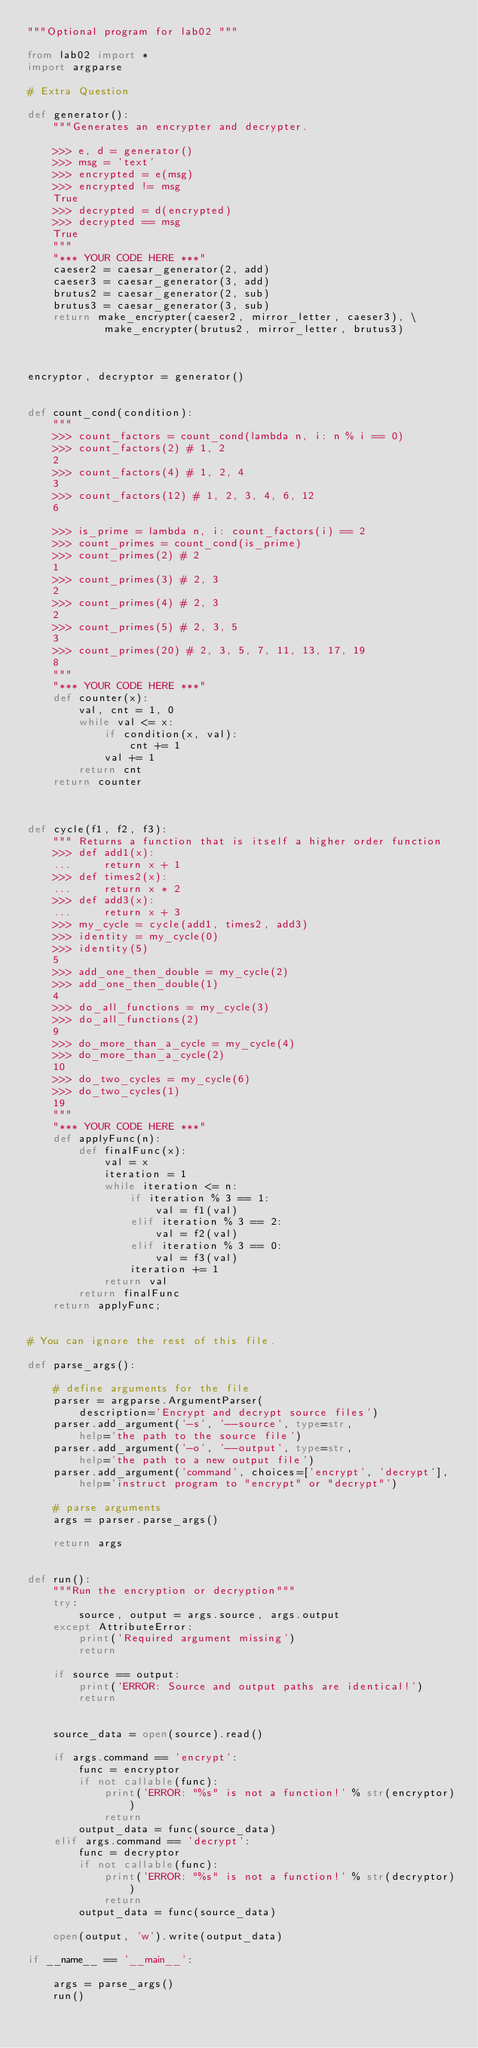<code> <loc_0><loc_0><loc_500><loc_500><_Python_>"""Optional program for lab02 """

from lab02 import *
import argparse

# Extra Question

def generator():
    """Generates an encrypter and decrypter.

    >>> e, d = generator()
    >>> msg = 'text'
    >>> encrypted = e(msg)
    >>> encrypted != msg
    True
    >>> decrypted = d(encrypted)
    >>> decrypted == msg
    True
    """
    "*** YOUR CODE HERE ***"
    caeser2 = caesar_generator(2, add)
    caeser3 = caesar_generator(3, add)
    brutus2 = caesar_generator(2, sub)
    brutus3 = caesar_generator(3, sub)
    return make_encrypter(caeser2, mirror_letter, caeser3), \
            make_encrypter(brutus2, mirror_letter, brutus3)
    


encryptor, decryptor = generator()


def count_cond(condition):
    """
    >>> count_factors = count_cond(lambda n, i: n % i == 0)
    >>> count_factors(2) # 1, 2
    2
    >>> count_factors(4) # 1, 2, 4
    3
    >>> count_factors(12) # 1, 2, 3, 4, 6, 12
    6

    >>> is_prime = lambda n, i: count_factors(i) == 2
    >>> count_primes = count_cond(is_prime)
    >>> count_primes(2) # 2
    1
    >>> count_primes(3) # 2, 3
    2
    >>> count_primes(4) # 2, 3
    2
    >>> count_primes(5) # 2, 3, 5
    3
    >>> count_primes(20) # 2, 3, 5, 7, 11, 13, 17, 19
    8
    """
    "*** YOUR CODE HERE ***"
    def counter(x):
        val, cnt = 1, 0
        while val <= x:
            if condition(x, val):
                cnt += 1
            val += 1
        return cnt
    return counter



def cycle(f1, f2, f3):
    """ Returns a function that is itself a higher order function
    >>> def add1(x):
    ...     return x + 1
    >>> def times2(x):
    ...     return x * 2
    >>> def add3(x):
    ...     return x + 3
    >>> my_cycle = cycle(add1, times2, add3)
    >>> identity = my_cycle(0)
    >>> identity(5)
    5
    >>> add_one_then_double = my_cycle(2)
    >>> add_one_then_double(1)
    4
    >>> do_all_functions = my_cycle(3)
    >>> do_all_functions(2)
    9
    >>> do_more_than_a_cycle = my_cycle(4)
    >>> do_more_than_a_cycle(2)
    10
    >>> do_two_cycles = my_cycle(6)
    >>> do_two_cycles(1)
    19
    """
    "*** YOUR CODE HERE ***"
    def applyFunc(n):
        def finalFunc(x):
            val = x
            iteration = 1
            while iteration <= n:
                if iteration % 3 == 1:
                    val = f1(val)
                elif iteration % 3 == 2:
                    val = f2(val)
                elif iteration % 3 == 0:
                    val = f3(val)
                iteration += 1
            return val
        return finalFunc
    return applyFunc;


# You can ignore the rest of this file.

def parse_args():

    # define arguments for the file
    parser = argparse.ArgumentParser(
        description='Encrypt and decrypt source files')
    parser.add_argument('-s', '--source', type=str,
        help='the path to the source file')
    parser.add_argument('-o', '--output', type=str,
        help='the path to a new output file')
    parser.add_argument('command', choices=['encrypt', 'decrypt'],
        help='instruct program to "encrypt" or "decrypt"')

    # parse arguments
    args = parser.parse_args()

    return args


def run():
    """Run the encryption or decryption"""
    try:
        source, output = args.source, args.output
    except AttributeError:
        print('Required argument missing')
        return

    if source == output:
        print('ERROR: Source and output paths are identical!')
        return


    source_data = open(source).read()

    if args.command == 'encrypt':
        func = encryptor
        if not callable(func):
            print('ERROR: "%s" is not a function!' % str(encryptor))
            return
        output_data = func(source_data)
    elif args.command == 'decrypt':
        func = decryptor
        if not callable(func):
            print('ERROR: "%s" is not a function!' % str(decryptor))
            return
        output_data = func(source_data)

    open(output, 'w').write(output_data)

if __name__ == '__main__':

    args = parse_args()
    run()
</code> 